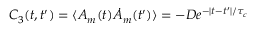<formula> <loc_0><loc_0><loc_500><loc_500>\begin{array} { r } { C _ { 3 } ( t , t ^ { \prime } ) = \langle A _ { m } ( t ) \dot { A } _ { m } ( t ^ { \prime } ) \rangle = - { D } e ^ { - | t - t ^ { \prime } | / \tau _ { c } } } \end{array}</formula> 